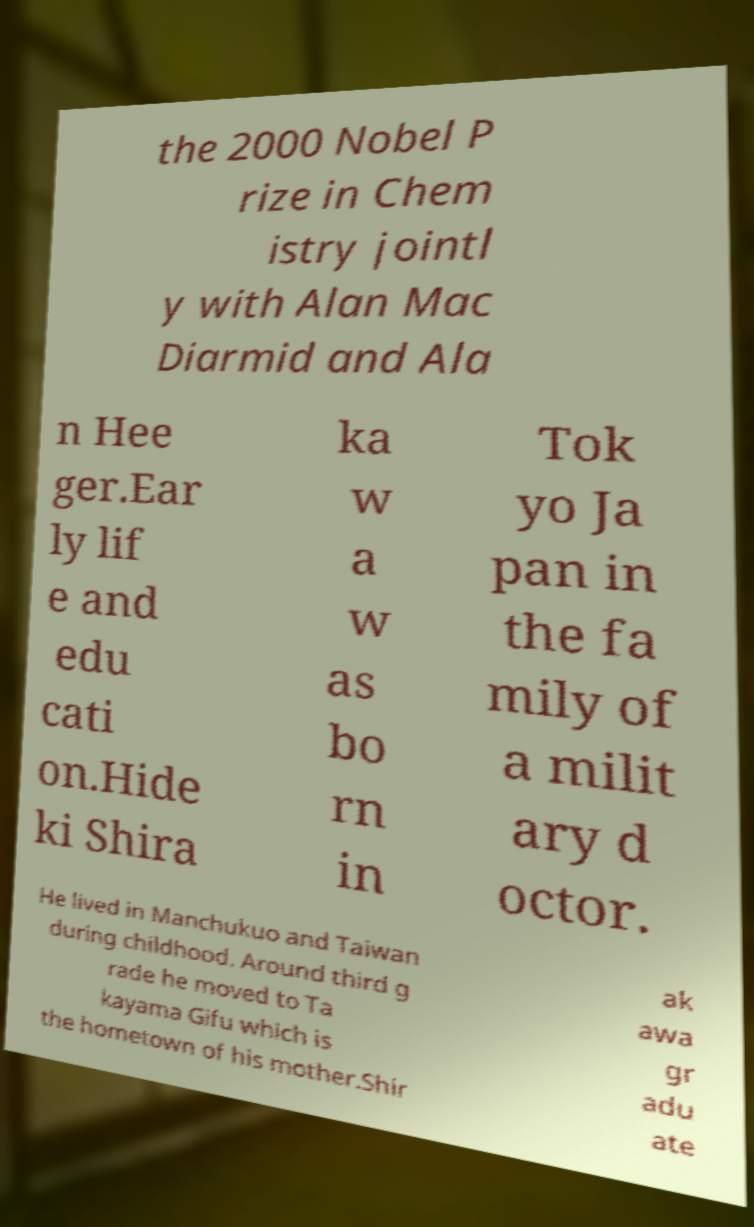For documentation purposes, I need the text within this image transcribed. Could you provide that? the 2000 Nobel P rize in Chem istry jointl y with Alan Mac Diarmid and Ala n Hee ger.Ear ly lif e and edu cati on.Hide ki Shira ka w a w as bo rn in Tok yo Ja pan in the fa mily of a milit ary d octor. He lived in Manchukuo and Taiwan during childhood. Around third g rade he moved to Ta kayama Gifu which is the hometown of his mother.Shir ak awa gr adu ate 